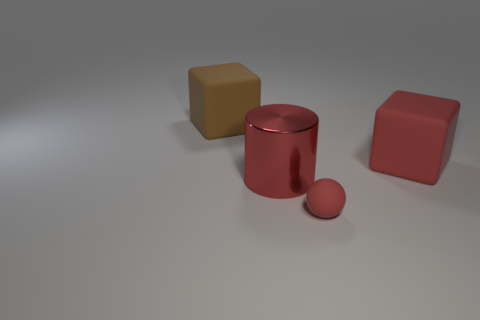Add 4 big rubber cubes. How many objects exist? 8 Subtract all spheres. How many objects are left? 3 Subtract all large green rubber cylinders. Subtract all red cylinders. How many objects are left? 3 Add 3 tiny things. How many tiny things are left? 4 Add 2 cyan metal blocks. How many cyan metal blocks exist? 2 Subtract 0 green spheres. How many objects are left? 4 